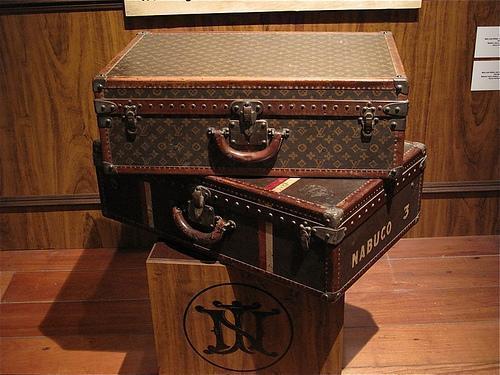How many suitcases are there?
Give a very brief answer. 2. How many white signs are there?
Give a very brief answer. 2. 